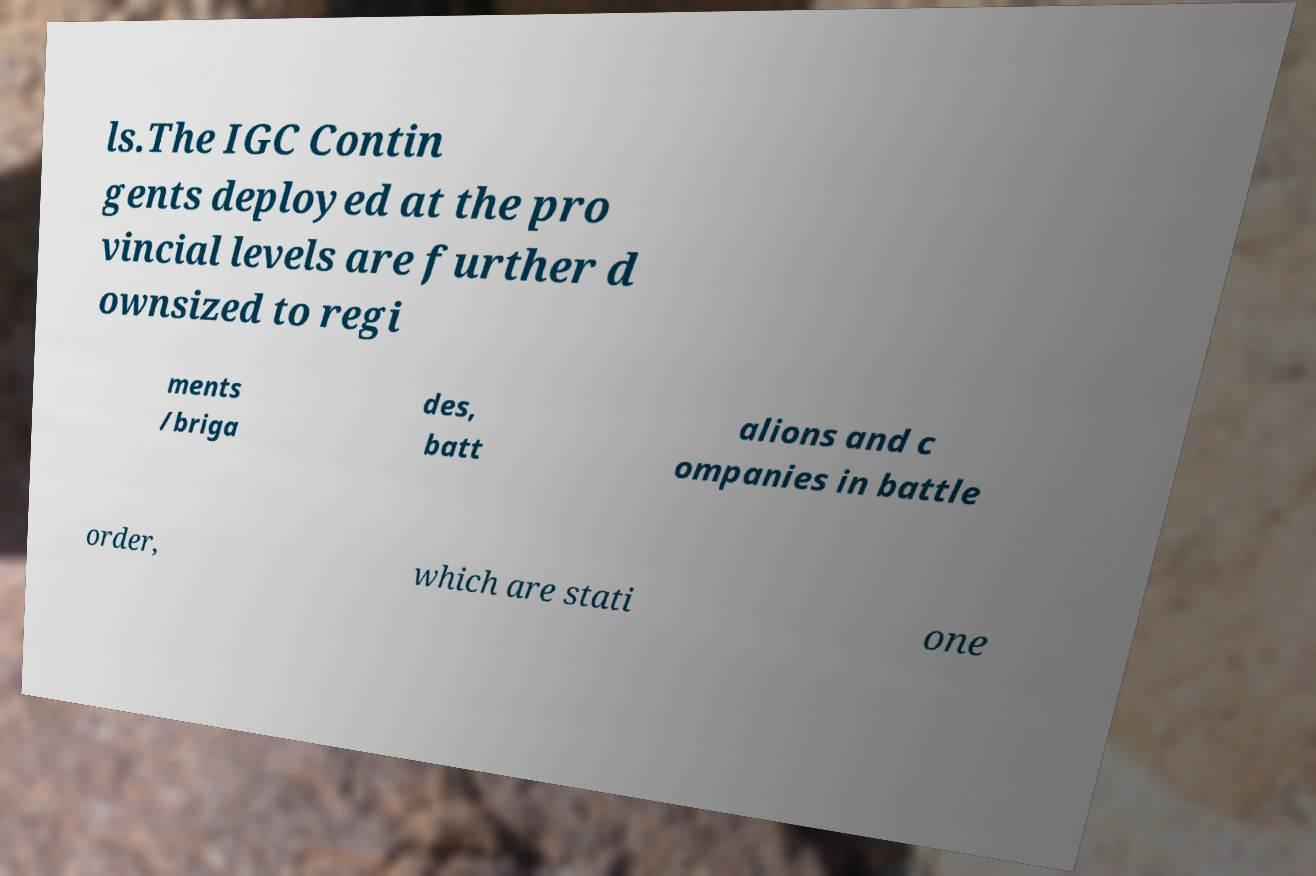What messages or text are displayed in this image? I need them in a readable, typed format. ls.The IGC Contin gents deployed at the pro vincial levels are further d ownsized to regi ments /briga des, batt alions and c ompanies in battle order, which are stati one 